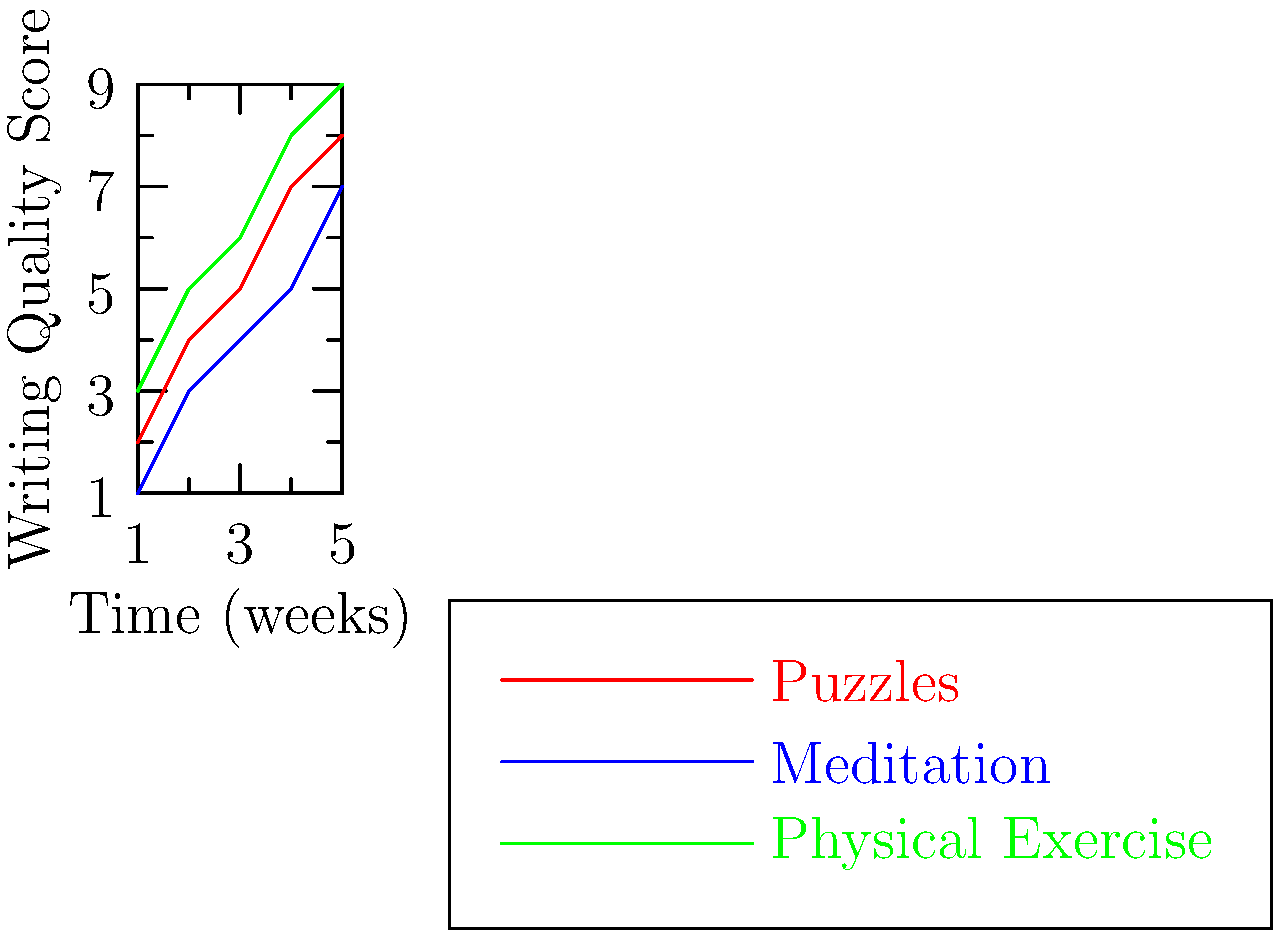Based on the graph showing the correlation between different cognitive exercises and improvements in writing quality over time, which exercise appears to have the most consistent positive impact on writing quality? To determine which exercise has the most consistent positive impact on writing quality, we need to analyze the slopes and patterns of each line:

1. Puzzles (red line):
   - Starts at 2 and ends at 8
   - Shows a steady increase but with some variation in slope

2. Meditation (blue line):
   - Starts at 1 and ends at 7
   - Shows a consistent increase but with a slightly lower overall improvement

3. Physical Exercise (green line):
   - Starts at 3 and ends at 9
   - Shows the most consistent upward trend with the least variation in slope

By comparing these trends:
- Physical Exercise (green) shows the most consistent upward trend
- It has the least variation in its slope
- It also achieves the highest overall improvement (from 3 to 9)

Therefore, based on this graph, Physical Exercise appears to have the most consistent positive impact on writing quality over time.
Answer: Physical Exercise 